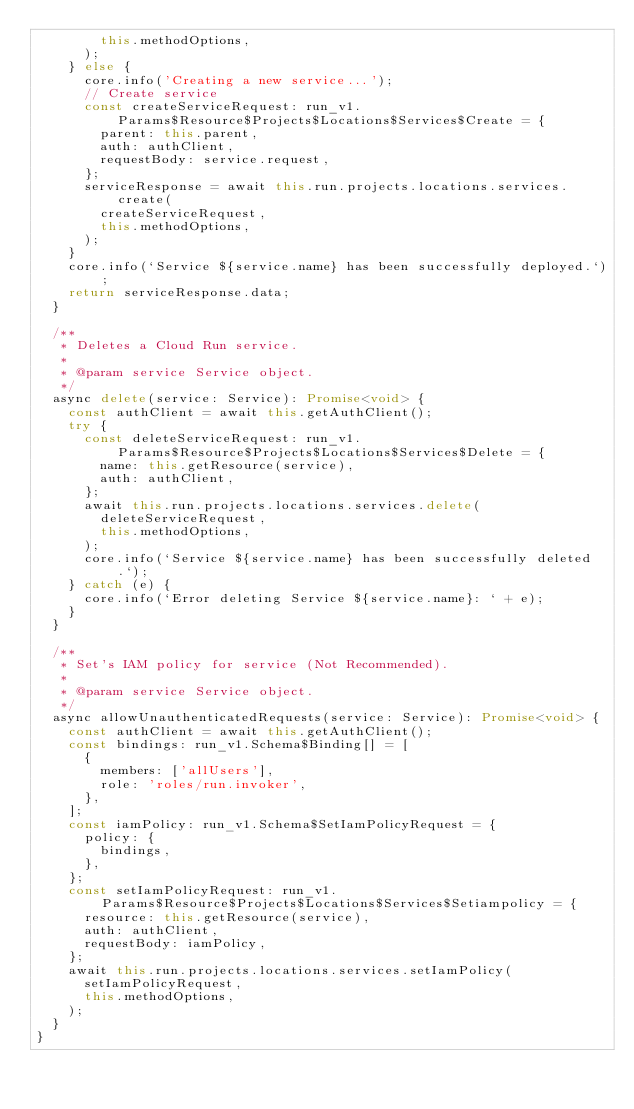<code> <loc_0><loc_0><loc_500><loc_500><_TypeScript_>        this.methodOptions,
      );
    } else {
      core.info('Creating a new service...');
      // Create service
      const createServiceRequest: run_v1.Params$Resource$Projects$Locations$Services$Create = {
        parent: this.parent,
        auth: authClient,
        requestBody: service.request,
      };
      serviceResponse = await this.run.projects.locations.services.create(
        createServiceRequest,
        this.methodOptions,
      );
    }
    core.info(`Service ${service.name} has been successfully deployed.`);
    return serviceResponse.data;
  }

  /**
   * Deletes a Cloud Run service.
   *
   * @param service Service object.
   */
  async delete(service: Service): Promise<void> {
    const authClient = await this.getAuthClient();
    try {
      const deleteServiceRequest: run_v1.Params$Resource$Projects$Locations$Services$Delete = {
        name: this.getResource(service),
        auth: authClient,
      };
      await this.run.projects.locations.services.delete(
        deleteServiceRequest,
        this.methodOptions,
      );
      core.info(`Service ${service.name} has been successfully deleted.`);
    } catch (e) {
      core.info(`Error deleting Service ${service.name}: ` + e);
    }
  }

  /**
   * Set's IAM policy for service (Not Recommended).
   *
   * @param service Service object.
   */
  async allowUnauthenticatedRequests(service: Service): Promise<void> {
    const authClient = await this.getAuthClient();
    const bindings: run_v1.Schema$Binding[] = [
      {
        members: ['allUsers'],
        role: 'roles/run.invoker',
      },
    ];
    const iamPolicy: run_v1.Schema$SetIamPolicyRequest = {
      policy: {
        bindings,
      },
    };
    const setIamPolicyRequest: run_v1.Params$Resource$Projects$Locations$Services$Setiampolicy = {
      resource: this.getResource(service),
      auth: authClient,
      requestBody: iamPolicy,
    };
    await this.run.projects.locations.services.setIamPolicy(
      setIamPolicyRequest,
      this.methodOptions,
    );
  }
}
</code> 